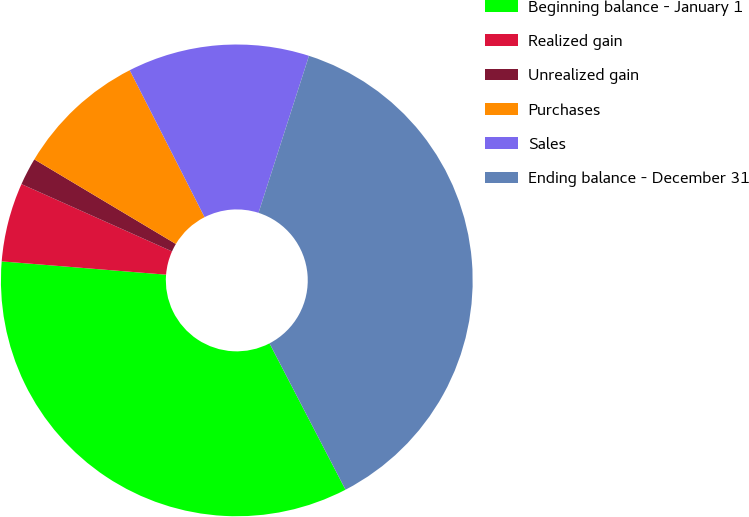<chart> <loc_0><loc_0><loc_500><loc_500><pie_chart><fcel>Beginning balance - January 1<fcel>Realized gain<fcel>Unrealized gain<fcel>Purchases<fcel>Sales<fcel>Ending balance - December 31<nl><fcel>33.91%<fcel>5.41%<fcel>1.88%<fcel>8.93%<fcel>12.45%<fcel>37.43%<nl></chart> 